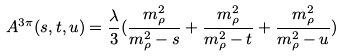<formula> <loc_0><loc_0><loc_500><loc_500>A ^ { 3 \pi } ( s , t , u ) = \frac { \lambda } { 3 } ( \frac { m _ { \rho } ^ { 2 } } { m _ { \rho } ^ { 2 } - s } + \frac { m _ { \rho } ^ { 2 } } { m _ { \rho } ^ { 2 } - t } + \frac { m _ { \rho } ^ { 2 } } { m _ { \rho } ^ { 2 } - u } )</formula> 